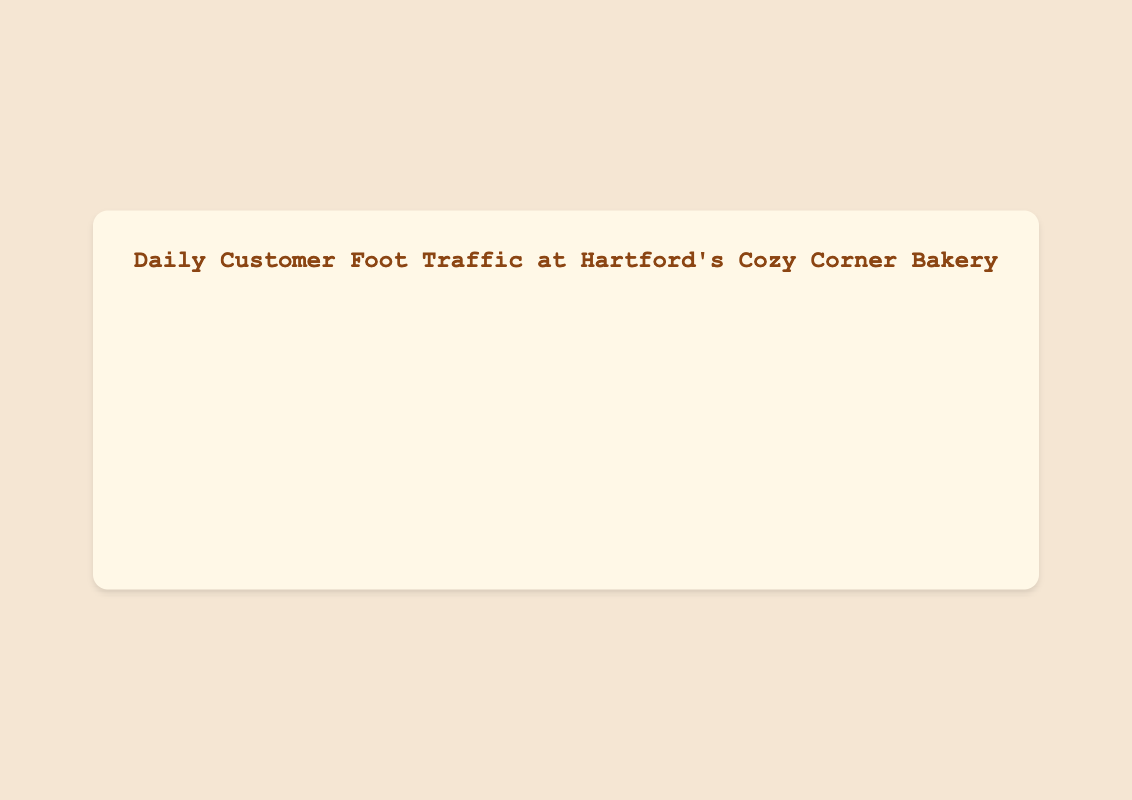What was the daily customer count on the busiest day over the last six months? The chart shows that the highest foot traffic occurred on "2023-10-10" with 275 customers.
Answer: 275 How did the customer foot traffic trend change from April to October? By observing the graph, customer traffic over the months gradually increases. In April, the foot traffic starts around 154 and escalates up to 275 by October.
Answer: Increased What is the average daily customer count in June? In June, take the daily counts (160, 167, 170, 175, 180, 185, 190, 200, 195, 188), sum them up to get 1810, then divide by 10.
Answer: 181 Compare the customer counts on "2023-07-04" and "2023-10-10". On which date did more customers visit? On "2023-07-04", 210 customers visited whereas on "2023-10-10" there were 275 customers. "2023-10-10" had more visitors.
Answer: 2023-10-10 During which month did the bakery experience the highest consistent customer increase week over week? The visual trend indicates that August shows a consistent and substantial increase in customer foot traffic every week.
Answer: August Which period saw a steep upward trend in customer foot traffic? From August to October, the chart displays a noticeable and steep upward trend in customer numbers.
Answer: August-October What is the total customer count across all days in April? Adding all the daily values in April (154 + 132 + 148 + 157 + 145 + 160 + 170 + 180 + 175 + 162) gives 1583.
Answer: 1583 Was the customer foot traffic in July generally higher or lower compared to May? Visually, the foot traffic in July is generally higher with peak counts going up to 218, compared to May's peak of 200.
Answer: Higher Identify any noticeable spikes in daily foot traffic. When did they occur? The notable spikes are on "2023-07-04" and "2023-10-10" where the customer traffic peaked at 210 and 275 respectively.
Answer: 2023-07-04, 2023-10-10 Did the bakery experience any drops in customer foot traffic? If yes, when? Although there are daily fluctuations, there are no significant drops in the overall trend. The graph shows a steady or increasing trend without major declines.
Answer: No significant drops 